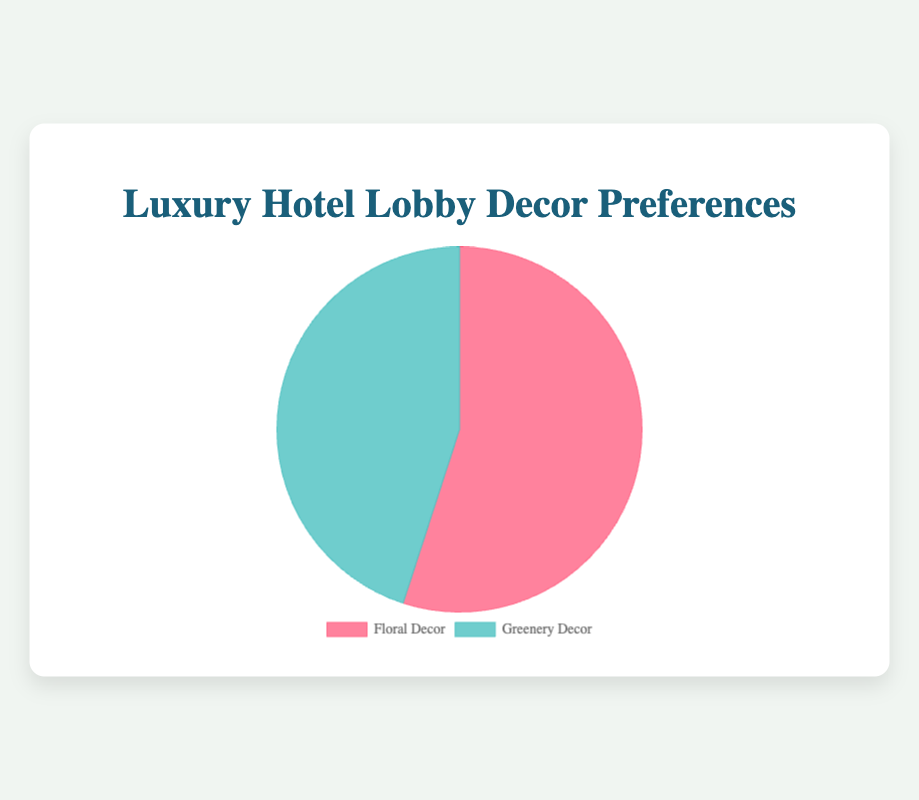What percentage of guests prefer floral decor compared to greenery decor? The pie chart shows two sections, one for Floral Decor and one for Greenery Decor. The percentage for Floral Decor is 55% and for Greenery Decor is 45%.
Answer: 55% prefer Floral Decor How much more do guests prefer floral decor over greenery decor? The percentage of guests preferring floral decor is 55% and for greenery decor is 45%. To find the difference, subtract 45% from 55%.
Answer: 10% How are the colors associated with each type of decor in the chart? The pie chart uses colors to differentiate between Floral Decor and Greenery Decor. Floral Decor is represented in red and Greenery Decor is represented in green.
Answer: Red for Floral, Green for Greenery What is the total sample size represented in the pie chart? The sample sizes for Floral Decor and Greenery Decor are given as 110 and 90, respectively. Adding these gives the total sample size of 110 + 90.
Answer: 200 If 110 guests prefer floral decor, how many guests prefer greenery decor? The total sample size is 200 guests, and 55% prefer floral decor which corresponds to 110 guests. This means the remaining percentage, 45%, prefer greenery decor. Calculate the number by multiplying 200 by 0.45.
Answer: 90 guests Which type of decor do guests generally prefer according to the pie chart? The pie chart shows that Floral Decor has a higher percentage (55%) compared to Greenery Decor (45%), indicating a general preference for Floral Decor.
Answer: Floral Decor By how many percentage points does floral decor lead over greenery decor? The pie chart shows Floral Decor at 55% and Greenery Decor at 45%. Subtracting 45 from 55 gives the lead in percentage points.
Answer: 10 percentage points Is the difference in guest preferences between the two decor types significant in the chart? A visual analysis of the chart shows a difference of 10 percentage points between Floral Decor (55%) and Greenery Decor (45%), which is a noticeable difference.
Answer: Yes, it is significant 